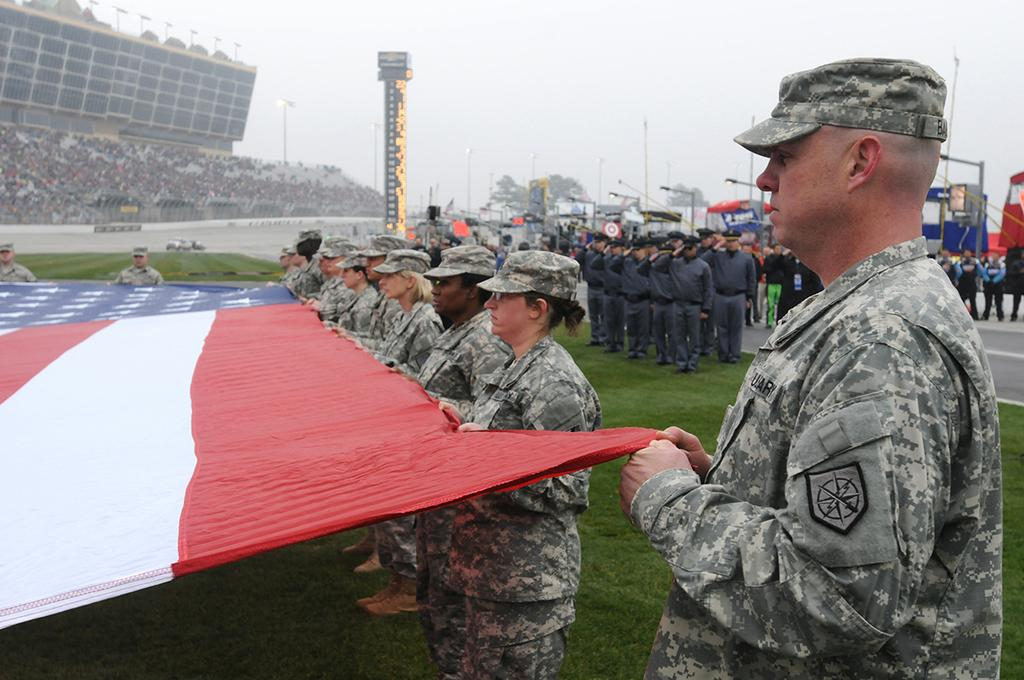What are the people in the image wearing? The people in the image are wearing military dress. What are the people holding in the image? The people are holding a flag. What can be seen in the background of the image? There is a crowd, light poles, trees, and grass visible in the background of the image. What type of plant is causing the disease in the image? There is no plant or disease present in the image. 